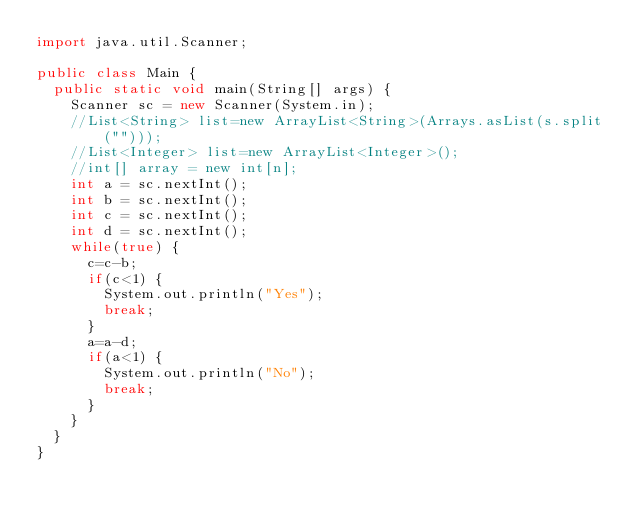<code> <loc_0><loc_0><loc_500><loc_500><_Java_>import java.util.Scanner;

public class Main {
	public static void main(String[] args) {
		Scanner sc = new Scanner(System.in);
		//List<String> list=new ArrayList<String>(Arrays.asList(s.split("")));
		//List<Integer> list=new ArrayList<Integer>();
		//int[] array = new int[n];
		int a = sc.nextInt();
		int b = sc.nextInt();
		int c = sc.nextInt();
		int d = sc.nextInt();
		while(true) {
			c=c-b;
			if(c<1) {
				System.out.println("Yes");
				break;
			}
			a=a-d;
			if(a<1) {
				System.out.println("No");
				break;
			}
		}
	}
}</code> 